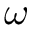Convert formula to latex. <formula><loc_0><loc_0><loc_500><loc_500>\omega</formula> 